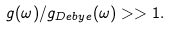Convert formula to latex. <formula><loc_0><loc_0><loc_500><loc_500>g ( \omega ) / g _ { D e b y e } ( \omega ) > > 1 .</formula> 